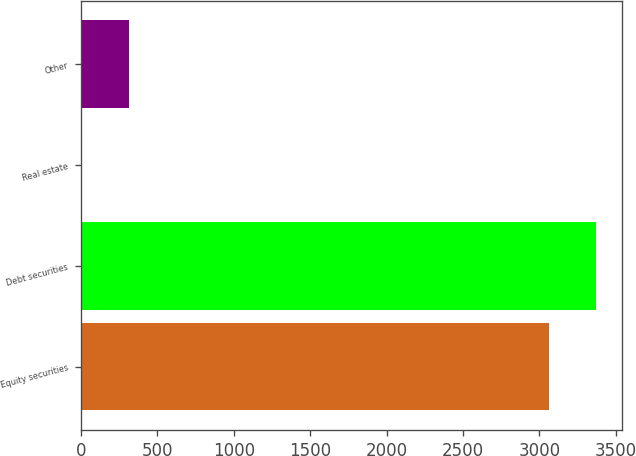Convert chart to OTSL. <chart><loc_0><loc_0><loc_500><loc_500><bar_chart><fcel>Equity securities<fcel>Debt securities<fcel>Real estate<fcel>Other<nl><fcel>3065<fcel>3370.5<fcel>10<fcel>315.5<nl></chart> 